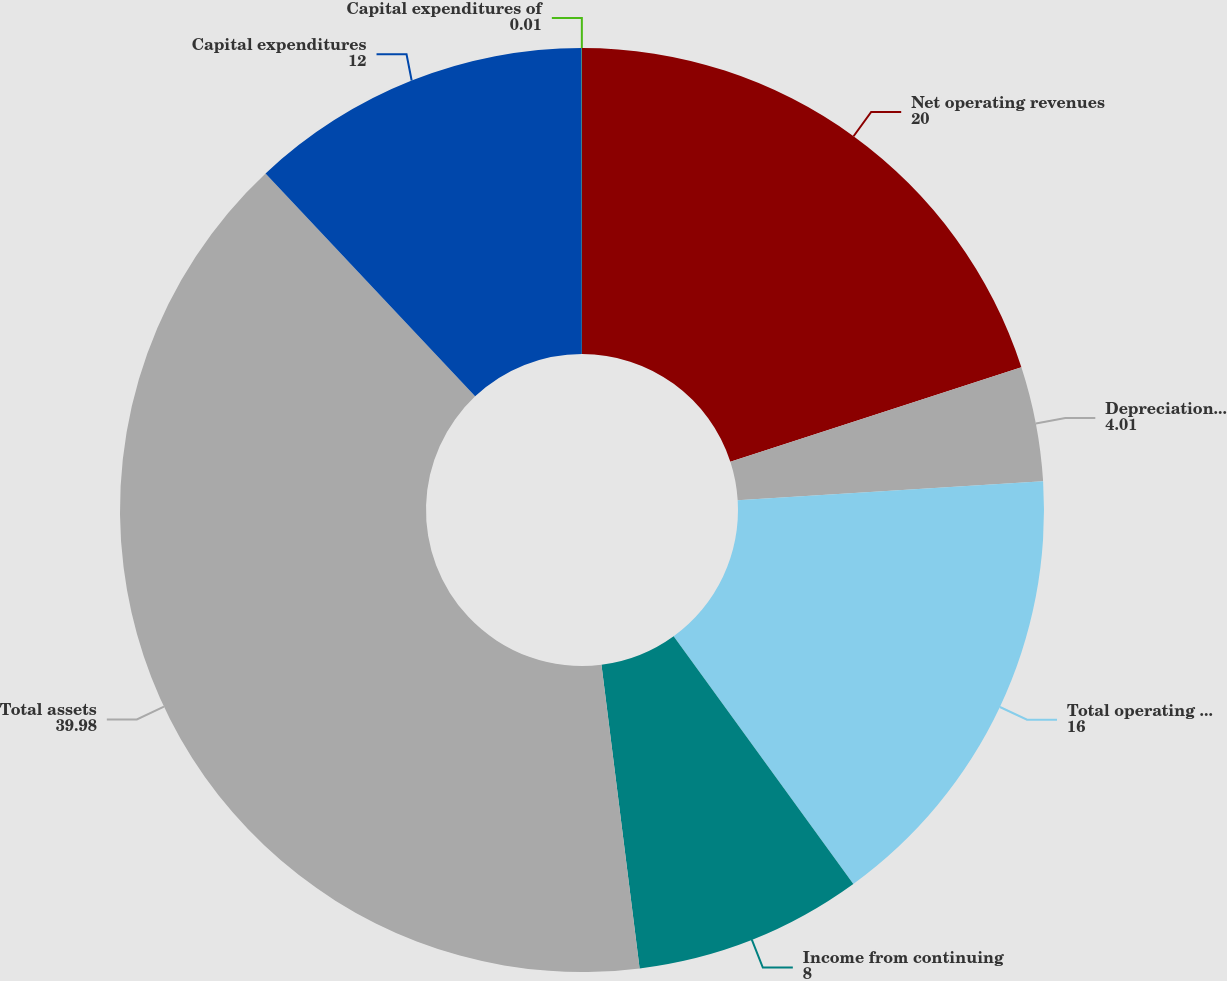Convert chart. <chart><loc_0><loc_0><loc_500><loc_500><pie_chart><fcel>Net operating revenues<fcel>Depreciation and amortization<fcel>Total operating expenses net<fcel>Income from continuing<fcel>Total assets<fcel>Capital expenditures<fcel>Capital expenditures of<nl><fcel>20.0%<fcel>4.01%<fcel>16.0%<fcel>8.0%<fcel>39.98%<fcel>12.0%<fcel>0.01%<nl></chart> 